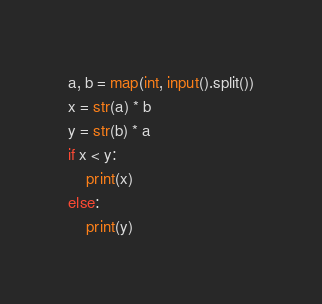Convert code to text. <code><loc_0><loc_0><loc_500><loc_500><_Python_>a, b = map(int, input().split())
x = str(a) * b
y = str(b) * a
if x < y:
    print(x)
else:
    print(y)</code> 